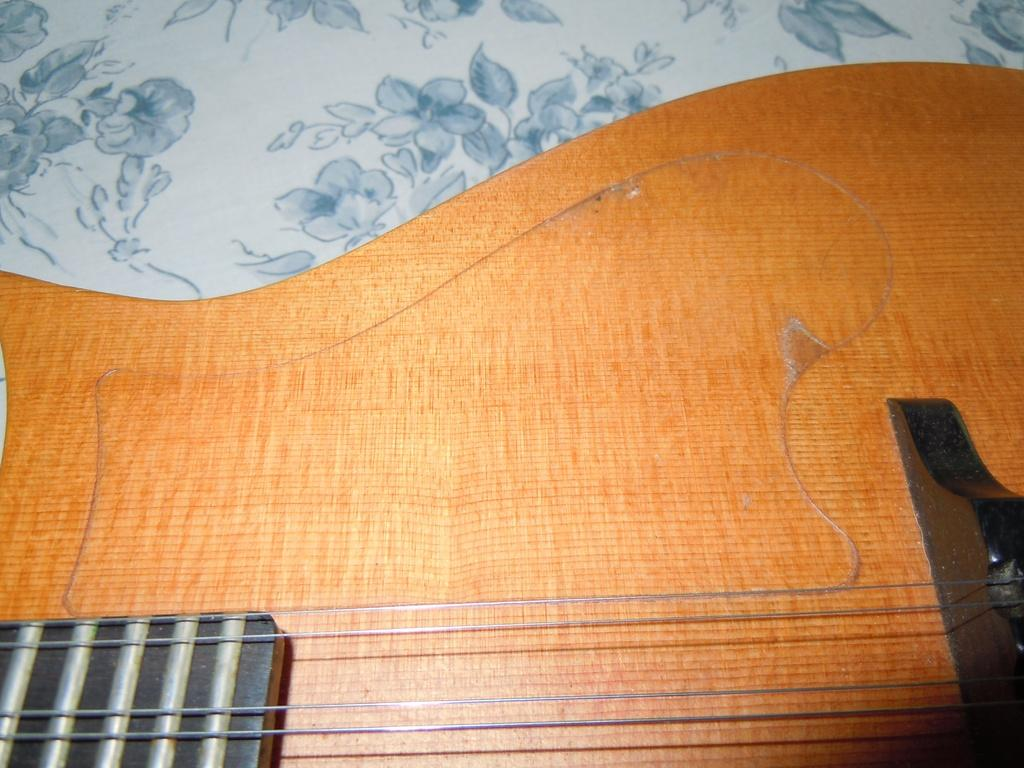What musical instrument is on the table in the image? There is a guitar on a table in the image. What type of car is parked next to the guitar in the image? There is no car present in the image; it only features a guitar on a table. How many legs does the guitar have in the image? Guitars do not have legs; they have a neck and a body. 